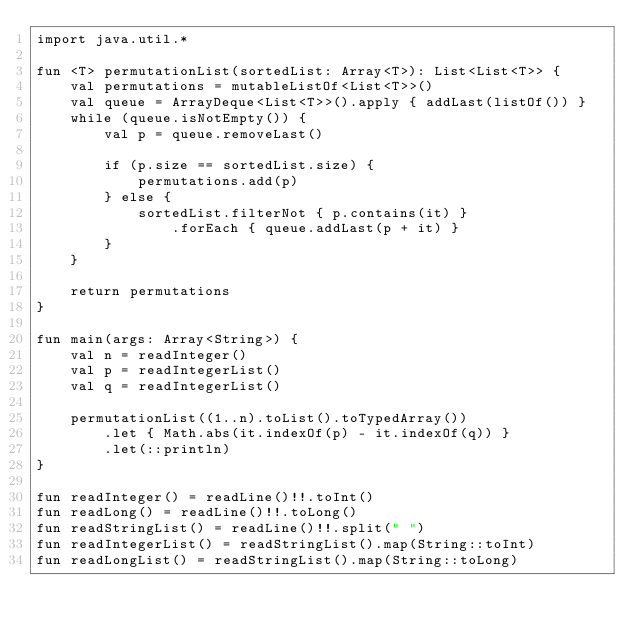Convert code to text. <code><loc_0><loc_0><loc_500><loc_500><_Kotlin_>import java.util.*

fun <T> permutationList(sortedList: Array<T>): List<List<T>> {
    val permutations = mutableListOf<List<T>>()
    val queue = ArrayDeque<List<T>>().apply { addLast(listOf()) }
    while (queue.isNotEmpty()) {
        val p = queue.removeLast()

        if (p.size == sortedList.size) {
            permutations.add(p)
        } else {
            sortedList.filterNot { p.contains(it) }
                .forEach { queue.addLast(p + it) }
        }
    }

    return permutations
}

fun main(args: Array<String>) {
    val n = readInteger()
    val p = readIntegerList()
    val q = readIntegerList()

    permutationList((1..n).toList().toTypedArray())
        .let { Math.abs(it.indexOf(p) - it.indexOf(q)) }
        .let(::println)
}

fun readInteger() = readLine()!!.toInt()
fun readLong() = readLine()!!.toLong()
fun readStringList() = readLine()!!.split(" ")
fun readIntegerList() = readStringList().map(String::toInt)
fun readLongList() = readStringList().map(String::toLong)
</code> 